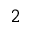Convert formula to latex. <formula><loc_0><loc_0><loc_500><loc_500>_ { 2 }</formula> 